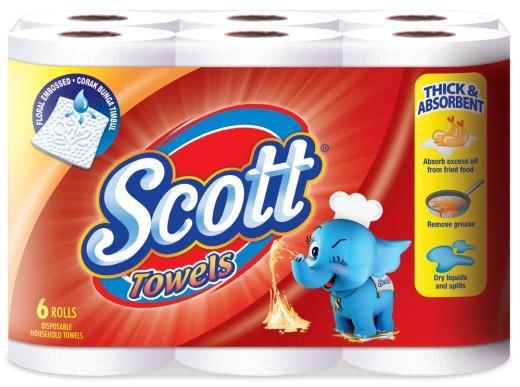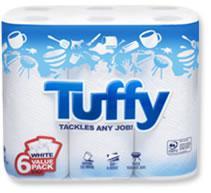The first image is the image on the left, the second image is the image on the right. Given the left and right images, does the statement "There are two multi-packs of paper towels." hold true? Answer yes or no. Yes. The first image is the image on the left, the second image is the image on the right. Assess this claim about the two images: "The left image shows one multi-roll package of towels with a starburst shape on the front of the pack, and the package on the right features a blue curving line.". Correct or not? Answer yes or no. No. 